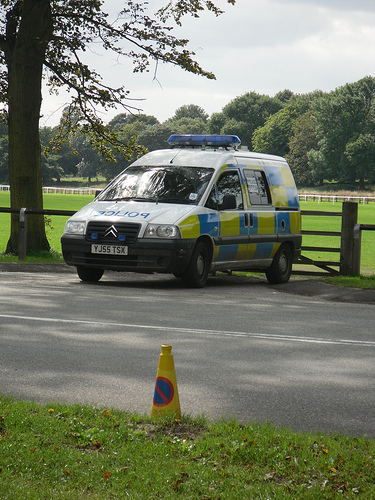<image>
Can you confirm if the cone is to the right of the police car? No. The cone is not to the right of the police car. The horizontal positioning shows a different relationship. Is the tree behind the car? No. The tree is not behind the car. From this viewpoint, the tree appears to be positioned elsewhere in the scene. 